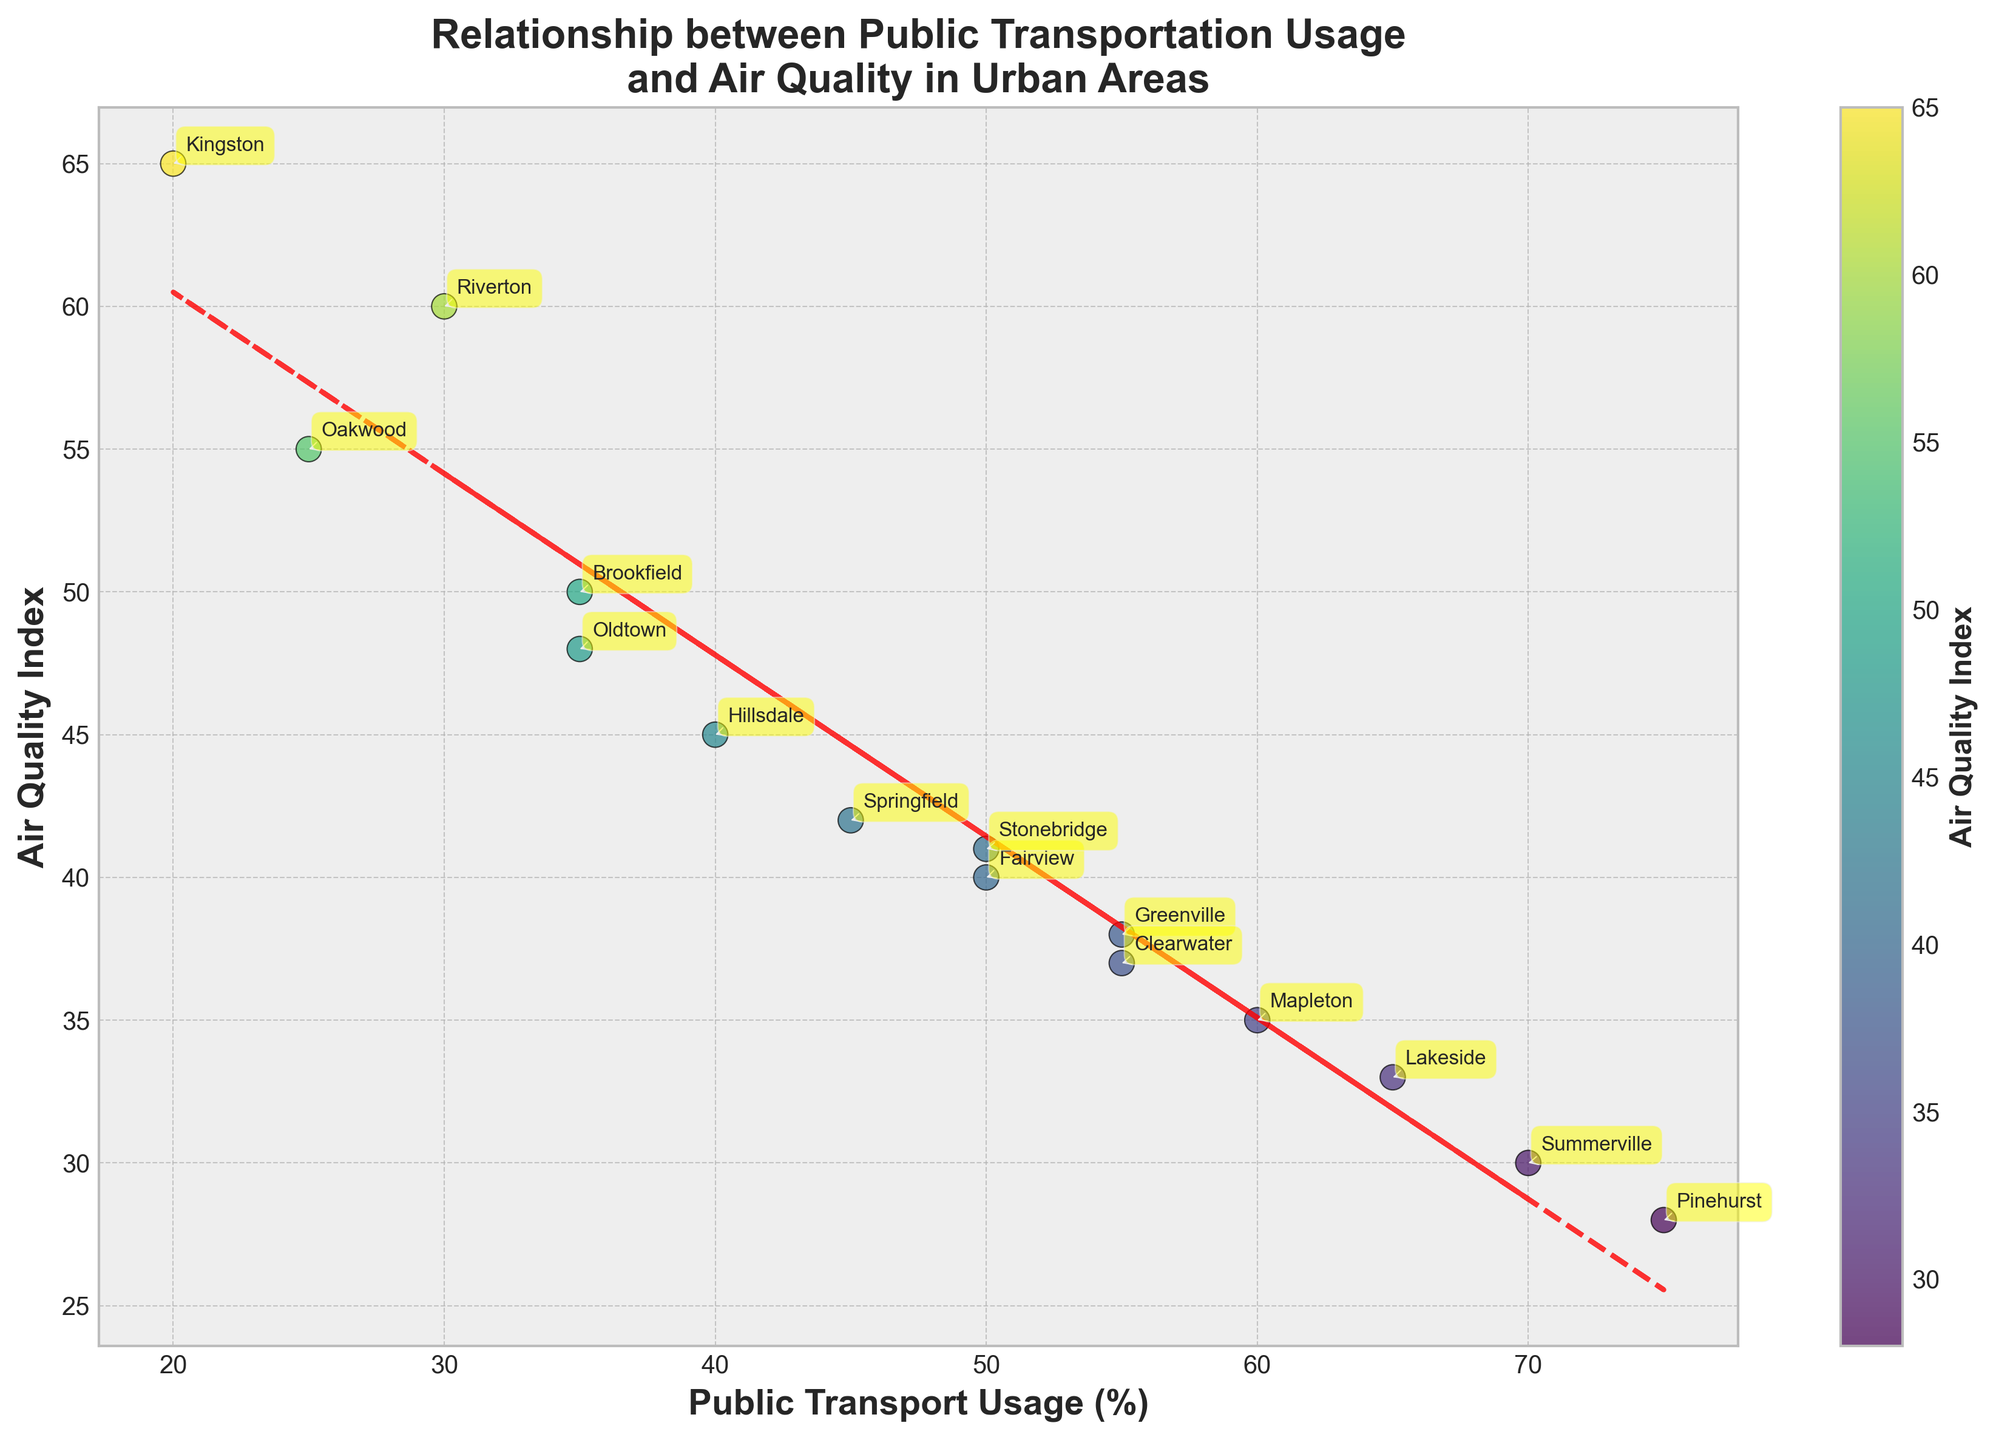What is the title of the plot? The title is displayed at the top of the plot and provides a clear summary of what the plot is about.
Answer: Relationship between Public Transportation Usage and Air Quality in Urban Areas What do the x-axis and y-axis represent? The x-axis and y-axis labels are indicated on the plot. The x-axis represents 'Public Transport Usage (%)', and the y-axis represents 'Air Quality Index'.
Answer: Public Transport Usage (%) and Air Quality Index How many data points are shown in the plot? Each city listed has a corresponding data point on the scatter plot. There are 15 cities, so there are 15 data points.
Answer: 15 Which city has the highest public transportation usage? By looking at the x-axis values, Pinehurst has the highest public transportation usage at 75%.
Answer: Pinehurst Is there a general trend between public transportation usage and air quality? The trend line in the plot helps indicate the relationship between the two variables. The red dashed line shows a downward trend, indicating that higher public transportation usage tends to correlate with better air quality (lower Air Quality Index).
Answer: Higher public transportation usage tends to correlate with better air quality Which city has the worst air quality, and what is its Public Transport Usage percentage? By identifying the highest Air Quality Index on the y-axis, Kingston has the highest value at 65. Kingston's Public Transport Usage is 20%.
Answer: Kingston, 20% What is the Air Quality Index value for Summerville? Summerville is labeled in the plot, and its position indicates its Air Quality Index is at the intersection of Public Transport Usage of 70% and Air Quality Index of 30.
Answer: 30 How does Springfield compare to Mapleton in terms of Public Transport Usage and Air Quality Index? Springfield has a Public Transport Usage of 45% and an Air Quality Index of 42. Mapleton has a higher Public Transport Usage of 60% and better Air Quality with an Index of 35.
Answer: Springfield has lower Public Transport Usage and worse Air Quality What is the average Air Quality Index for all the cities combined? Sum all Air Quality Index values: (42 + 38 + 60 + 35 + 40 + 33 + 45 + 50 + 37 + 30 + 55 + 65 + 41 + 28 + 48) = 647. Divide by the total number of cities, 15: 647 / 15 ≈ 43.13.
Answer: 43.13 Based on the trend line, estimate the Air Quality Index for a city with 45% Public Transport Usage. The trend line equation (derived from polyfit) can be used to estimate this. By locating the trend line at 45% on the x-axis, the Air Quality Index is approximately between 40 and 45.
Answer: Around 42 